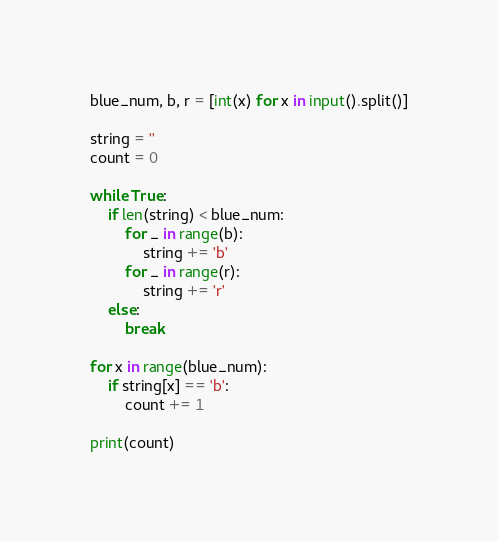Convert code to text. <code><loc_0><loc_0><loc_500><loc_500><_Python_>blue_num, b, r = [int(x) for x in input().split()]

string = ''
count = 0

while True:
    if len(string) < blue_num:
        for _ in range(b):
            string += 'b'
        for _ in range(r):
            string += 'r'
    else:
        break

for x in range(blue_num):
    if string[x] == 'b':
        count += 1

print(count)</code> 